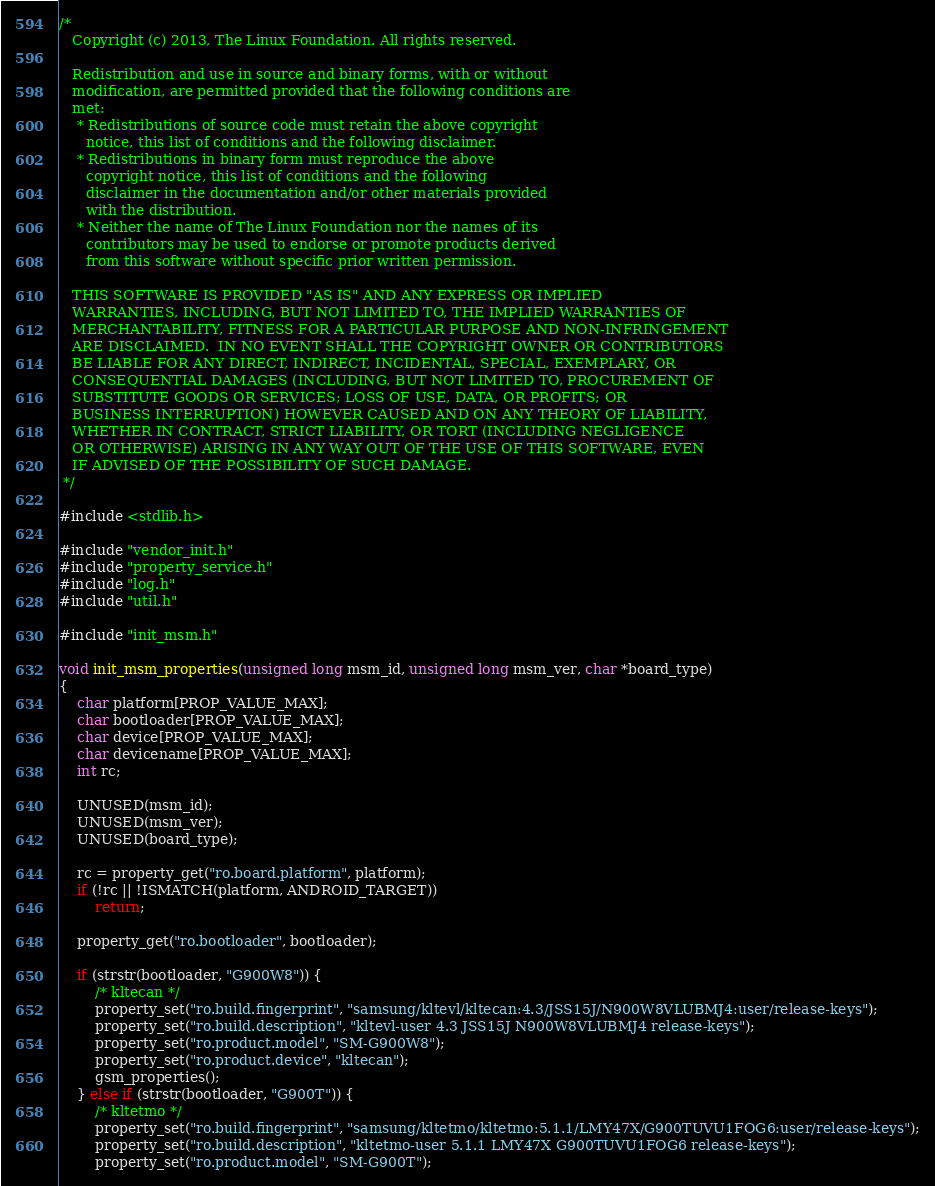Convert code to text. <code><loc_0><loc_0><loc_500><loc_500><_C_>/*
   Copyright (c) 2013, The Linux Foundation. All rights reserved.

   Redistribution and use in source and binary forms, with or without
   modification, are permitted provided that the following conditions are
   met:
    * Redistributions of source code must retain the above copyright
      notice, this list of conditions and the following disclaimer.
    * Redistributions in binary form must reproduce the above
      copyright notice, this list of conditions and the following
      disclaimer in the documentation and/or other materials provided
      with the distribution.
    * Neither the name of The Linux Foundation nor the names of its
      contributors may be used to endorse or promote products derived
      from this software without specific prior written permission.

   THIS SOFTWARE IS PROVIDED "AS IS" AND ANY EXPRESS OR IMPLIED
   WARRANTIES, INCLUDING, BUT NOT LIMITED TO, THE IMPLIED WARRANTIES OF
   MERCHANTABILITY, FITNESS FOR A PARTICULAR PURPOSE AND NON-INFRINGEMENT
   ARE DISCLAIMED.  IN NO EVENT SHALL THE COPYRIGHT OWNER OR CONTRIBUTORS
   BE LIABLE FOR ANY DIRECT, INDIRECT, INCIDENTAL, SPECIAL, EXEMPLARY, OR
   CONSEQUENTIAL DAMAGES (INCLUDING, BUT NOT LIMITED TO, PROCUREMENT OF
   SUBSTITUTE GOODS OR SERVICES; LOSS OF USE, DATA, OR PROFITS; OR
   BUSINESS INTERRUPTION) HOWEVER CAUSED AND ON ANY THEORY OF LIABILITY,
   WHETHER IN CONTRACT, STRICT LIABILITY, OR TORT (INCLUDING NEGLIGENCE
   OR OTHERWISE) ARISING IN ANY WAY OUT OF THE USE OF THIS SOFTWARE, EVEN
   IF ADVISED OF THE POSSIBILITY OF SUCH DAMAGE.
 */

#include <stdlib.h>

#include "vendor_init.h"
#include "property_service.h"
#include "log.h"
#include "util.h"

#include "init_msm.h"

void init_msm_properties(unsigned long msm_id, unsigned long msm_ver, char *board_type)
{
    char platform[PROP_VALUE_MAX];
    char bootloader[PROP_VALUE_MAX];
    char device[PROP_VALUE_MAX];
    char devicename[PROP_VALUE_MAX];
    int rc;

    UNUSED(msm_id);
    UNUSED(msm_ver);
    UNUSED(board_type);

    rc = property_get("ro.board.platform", platform);
    if (!rc || !ISMATCH(platform, ANDROID_TARGET))
        return;

    property_get("ro.bootloader", bootloader);

    if (strstr(bootloader, "G900W8")) {
        /* kltecan */
        property_set("ro.build.fingerprint", "samsung/kltevl/kltecan:4.3/JSS15J/N900W8VLUBMJ4:user/release-keys");
        property_set("ro.build.description", "kltevl-user 4.3 JSS15J N900W8VLUBMJ4 release-keys");
        property_set("ro.product.model", "SM-G900W8");
        property_set("ro.product.device", "kltecan");
        gsm_properties();
    } else if (strstr(bootloader, "G900T")) {
        /* kltetmo */
        property_set("ro.build.fingerprint", "samsung/kltetmo/kltetmo:5.1.1/LMY47X/G900TUVU1FOG6:user/release-keys");
        property_set("ro.build.description", "kltetmo-user 5.1.1 LMY47X G900TUVU1FOG6 release-keys");
        property_set("ro.product.model", "SM-G900T");</code> 